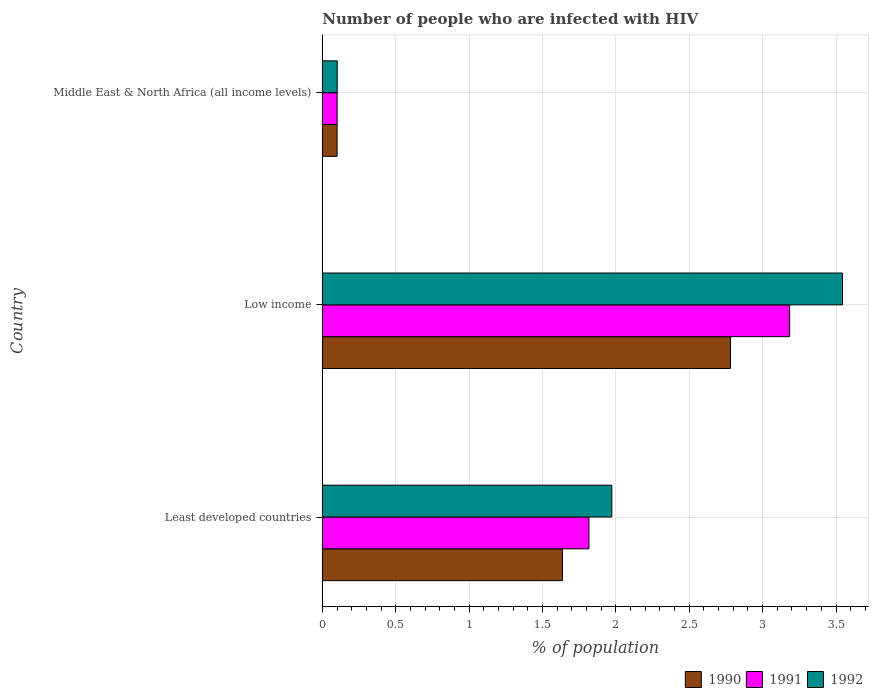How many different coloured bars are there?
Offer a terse response. 3. How many groups of bars are there?
Your answer should be compact. 3. Are the number of bars per tick equal to the number of legend labels?
Your answer should be compact. Yes. What is the label of the 3rd group of bars from the top?
Your answer should be compact. Least developed countries. What is the percentage of HIV infected population in in 1992 in Low income?
Your response must be concise. 3.54. Across all countries, what is the maximum percentage of HIV infected population in in 1990?
Keep it short and to the point. 2.78. Across all countries, what is the minimum percentage of HIV infected population in in 1992?
Provide a succinct answer. 0.1. In which country was the percentage of HIV infected population in in 1992 maximum?
Provide a short and direct response. Low income. In which country was the percentage of HIV infected population in in 1990 minimum?
Your response must be concise. Middle East & North Africa (all income levels). What is the total percentage of HIV infected population in in 1991 in the graph?
Your answer should be very brief. 5.1. What is the difference between the percentage of HIV infected population in in 1990 in Least developed countries and that in Middle East & North Africa (all income levels)?
Give a very brief answer. 1.54. What is the difference between the percentage of HIV infected population in in 1991 in Middle East & North Africa (all income levels) and the percentage of HIV infected population in in 1990 in Least developed countries?
Offer a very short reply. -1.54. What is the average percentage of HIV infected population in in 1990 per country?
Offer a terse response. 1.51. What is the difference between the percentage of HIV infected population in in 1991 and percentage of HIV infected population in in 1992 in Middle East & North Africa (all income levels)?
Make the answer very short. -0. What is the ratio of the percentage of HIV infected population in in 1992 in Least developed countries to that in Middle East & North Africa (all income levels)?
Ensure brevity in your answer.  19.43. Is the difference between the percentage of HIV infected population in in 1991 in Least developed countries and Low income greater than the difference between the percentage of HIV infected population in in 1992 in Least developed countries and Low income?
Your answer should be compact. Yes. What is the difference between the highest and the second highest percentage of HIV infected population in in 1991?
Offer a terse response. 1.37. What is the difference between the highest and the lowest percentage of HIV infected population in in 1991?
Offer a very short reply. 3.08. Is it the case that in every country, the sum of the percentage of HIV infected population in in 1990 and percentage of HIV infected population in in 1992 is greater than the percentage of HIV infected population in in 1991?
Give a very brief answer. Yes. How many countries are there in the graph?
Provide a short and direct response. 3. Does the graph contain grids?
Your response must be concise. Yes. Where does the legend appear in the graph?
Provide a short and direct response. Bottom right. What is the title of the graph?
Keep it short and to the point. Number of people who are infected with HIV. What is the label or title of the X-axis?
Offer a terse response. % of population. What is the label or title of the Y-axis?
Your answer should be compact. Country. What is the % of population in 1990 in Least developed countries?
Offer a terse response. 1.64. What is the % of population of 1991 in Least developed countries?
Your response must be concise. 1.82. What is the % of population in 1992 in Least developed countries?
Offer a very short reply. 1.97. What is the % of population of 1990 in Low income?
Your answer should be very brief. 2.78. What is the % of population of 1991 in Low income?
Ensure brevity in your answer.  3.18. What is the % of population of 1992 in Low income?
Your response must be concise. 3.54. What is the % of population of 1990 in Middle East & North Africa (all income levels)?
Your answer should be very brief. 0.1. What is the % of population of 1991 in Middle East & North Africa (all income levels)?
Keep it short and to the point. 0.1. What is the % of population of 1992 in Middle East & North Africa (all income levels)?
Keep it short and to the point. 0.1. Across all countries, what is the maximum % of population in 1990?
Make the answer very short. 2.78. Across all countries, what is the maximum % of population in 1991?
Make the answer very short. 3.18. Across all countries, what is the maximum % of population of 1992?
Your answer should be very brief. 3.54. Across all countries, what is the minimum % of population in 1990?
Offer a very short reply. 0.1. Across all countries, what is the minimum % of population of 1991?
Your answer should be compact. 0.1. Across all countries, what is the minimum % of population of 1992?
Give a very brief answer. 0.1. What is the total % of population of 1990 in the graph?
Your response must be concise. 4.52. What is the total % of population in 1991 in the graph?
Your answer should be very brief. 5.1. What is the total % of population in 1992 in the graph?
Your answer should be compact. 5.62. What is the difference between the % of population of 1990 in Least developed countries and that in Low income?
Your response must be concise. -1.14. What is the difference between the % of population in 1991 in Least developed countries and that in Low income?
Give a very brief answer. -1.37. What is the difference between the % of population in 1992 in Least developed countries and that in Low income?
Make the answer very short. -1.57. What is the difference between the % of population in 1990 in Least developed countries and that in Middle East & North Africa (all income levels)?
Make the answer very short. 1.54. What is the difference between the % of population in 1991 in Least developed countries and that in Middle East & North Africa (all income levels)?
Your response must be concise. 1.72. What is the difference between the % of population of 1992 in Least developed countries and that in Middle East & North Africa (all income levels)?
Offer a very short reply. 1.87. What is the difference between the % of population of 1990 in Low income and that in Middle East & North Africa (all income levels)?
Your answer should be very brief. 2.68. What is the difference between the % of population in 1991 in Low income and that in Middle East & North Africa (all income levels)?
Make the answer very short. 3.08. What is the difference between the % of population of 1992 in Low income and that in Middle East & North Africa (all income levels)?
Make the answer very short. 3.44. What is the difference between the % of population in 1990 in Least developed countries and the % of population in 1991 in Low income?
Provide a succinct answer. -1.55. What is the difference between the % of population in 1990 in Least developed countries and the % of population in 1992 in Low income?
Your answer should be very brief. -1.91. What is the difference between the % of population of 1991 in Least developed countries and the % of population of 1992 in Low income?
Give a very brief answer. -1.73. What is the difference between the % of population in 1990 in Least developed countries and the % of population in 1991 in Middle East & North Africa (all income levels)?
Your answer should be compact. 1.54. What is the difference between the % of population in 1990 in Least developed countries and the % of population in 1992 in Middle East & North Africa (all income levels)?
Provide a short and direct response. 1.53. What is the difference between the % of population in 1991 in Least developed countries and the % of population in 1992 in Middle East & North Africa (all income levels)?
Provide a succinct answer. 1.72. What is the difference between the % of population in 1990 in Low income and the % of population in 1991 in Middle East & North Africa (all income levels)?
Your response must be concise. 2.68. What is the difference between the % of population in 1990 in Low income and the % of population in 1992 in Middle East & North Africa (all income levels)?
Provide a short and direct response. 2.68. What is the difference between the % of population of 1991 in Low income and the % of population of 1992 in Middle East & North Africa (all income levels)?
Make the answer very short. 3.08. What is the average % of population in 1990 per country?
Offer a terse response. 1.51. What is the average % of population in 1991 per country?
Provide a short and direct response. 1.7. What is the average % of population in 1992 per country?
Offer a very short reply. 1.87. What is the difference between the % of population of 1990 and % of population of 1991 in Least developed countries?
Provide a short and direct response. -0.18. What is the difference between the % of population of 1990 and % of population of 1992 in Least developed countries?
Offer a very short reply. -0.34. What is the difference between the % of population of 1991 and % of population of 1992 in Least developed countries?
Keep it short and to the point. -0.16. What is the difference between the % of population in 1990 and % of population in 1991 in Low income?
Give a very brief answer. -0.4. What is the difference between the % of population of 1990 and % of population of 1992 in Low income?
Your answer should be very brief. -0.76. What is the difference between the % of population of 1991 and % of population of 1992 in Low income?
Offer a very short reply. -0.36. What is the difference between the % of population of 1990 and % of population of 1991 in Middle East & North Africa (all income levels)?
Make the answer very short. -0. What is the difference between the % of population of 1990 and % of population of 1992 in Middle East & North Africa (all income levels)?
Provide a short and direct response. -0. What is the difference between the % of population of 1991 and % of population of 1992 in Middle East & North Africa (all income levels)?
Your answer should be very brief. -0. What is the ratio of the % of population of 1990 in Least developed countries to that in Low income?
Give a very brief answer. 0.59. What is the ratio of the % of population in 1991 in Least developed countries to that in Low income?
Your answer should be very brief. 0.57. What is the ratio of the % of population in 1992 in Least developed countries to that in Low income?
Keep it short and to the point. 0.56. What is the ratio of the % of population of 1990 in Least developed countries to that in Middle East & North Africa (all income levels)?
Your answer should be compact. 16.27. What is the ratio of the % of population of 1991 in Least developed countries to that in Middle East & North Africa (all income levels)?
Provide a succinct answer. 18.01. What is the ratio of the % of population in 1992 in Least developed countries to that in Middle East & North Africa (all income levels)?
Offer a very short reply. 19.43. What is the ratio of the % of population of 1990 in Low income to that in Middle East & North Africa (all income levels)?
Make the answer very short. 27.64. What is the ratio of the % of population in 1991 in Low income to that in Middle East & North Africa (all income levels)?
Offer a very short reply. 31.56. What is the ratio of the % of population in 1992 in Low income to that in Middle East & North Africa (all income levels)?
Make the answer very short. 34.92. What is the difference between the highest and the second highest % of population of 1990?
Offer a very short reply. 1.14. What is the difference between the highest and the second highest % of population of 1991?
Make the answer very short. 1.37. What is the difference between the highest and the second highest % of population in 1992?
Provide a succinct answer. 1.57. What is the difference between the highest and the lowest % of population in 1990?
Give a very brief answer. 2.68. What is the difference between the highest and the lowest % of population of 1991?
Your answer should be very brief. 3.08. What is the difference between the highest and the lowest % of population in 1992?
Your answer should be compact. 3.44. 